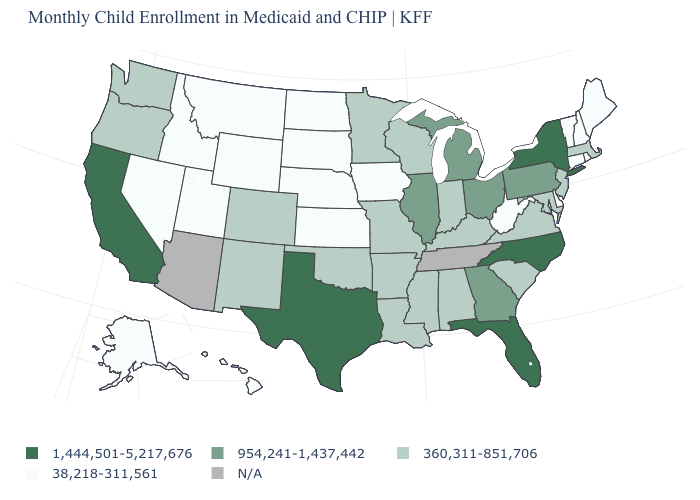Is the legend a continuous bar?
Short answer required. No. What is the value of California?
Concise answer only. 1,444,501-5,217,676. What is the value of Maryland?
Be succinct. 360,311-851,706. What is the value of Texas?
Write a very short answer. 1,444,501-5,217,676. Name the states that have a value in the range N/A?
Answer briefly. Arizona, Tennessee. Among the states that border New Mexico , does Colorado have the lowest value?
Short answer required. No. Name the states that have a value in the range 360,311-851,706?
Concise answer only. Alabama, Arkansas, Colorado, Indiana, Kentucky, Louisiana, Maryland, Massachusetts, Minnesota, Mississippi, Missouri, New Jersey, New Mexico, Oklahoma, Oregon, South Carolina, Virginia, Washington, Wisconsin. What is the value of California?
Short answer required. 1,444,501-5,217,676. Does the first symbol in the legend represent the smallest category?
Keep it brief. No. What is the highest value in states that border Maine?
Quick response, please. 38,218-311,561. Does Rhode Island have the lowest value in the Northeast?
Give a very brief answer. Yes. Among the states that border Alabama , does Florida have the highest value?
Give a very brief answer. Yes. What is the lowest value in the South?
Concise answer only. 38,218-311,561. 